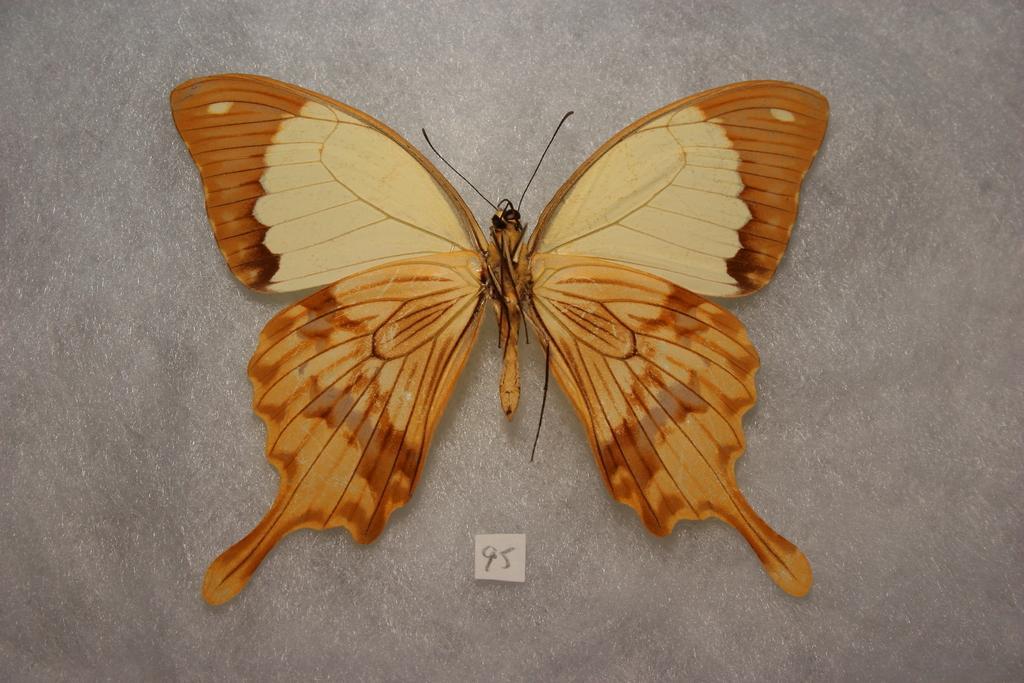Please provide a concise description of this image. This image consists of a butterfly in brown color. At the bottom, we can see a small piece of paper. The background is gray in color. 